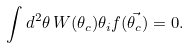Convert formula to latex. <formula><loc_0><loc_0><loc_500><loc_500>\int d ^ { 2 } \theta \, W ( \theta _ { c } ) \theta _ { i } f ( \vec { \theta _ { c } } ) = 0 .</formula> 